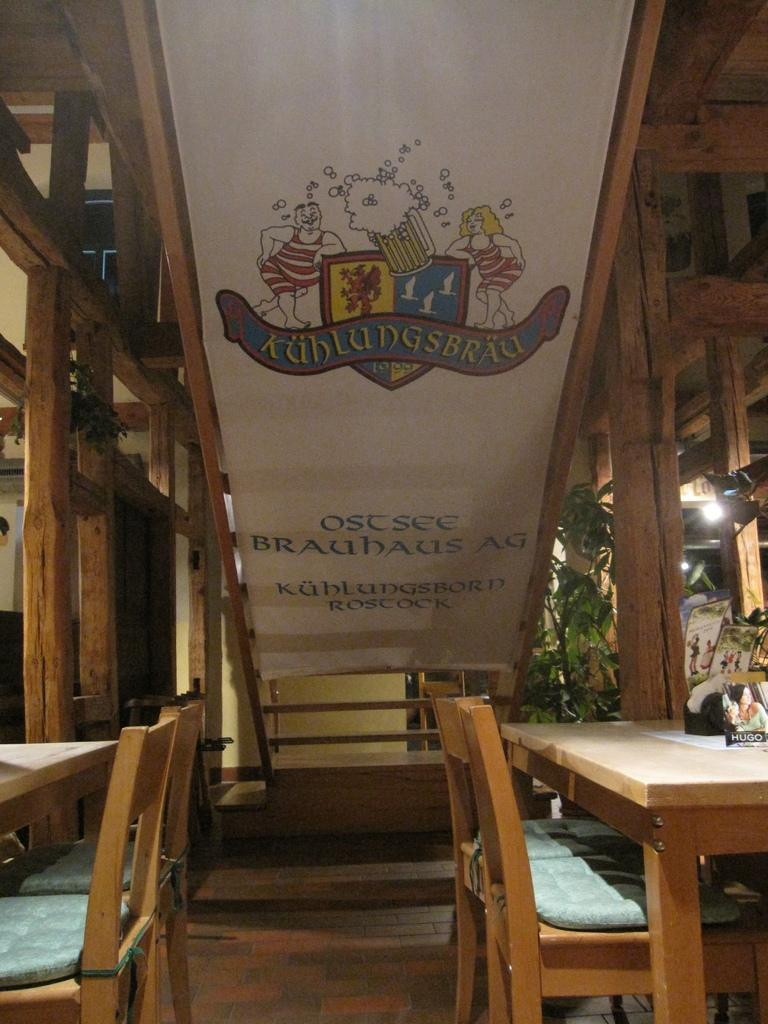What type of furniture is present in the image? There are tables and chairs in the image. What can be seen to the right in the image? There are boards to the right in the image. What is visible in the background of the image? There are boards, plants, light, and wooden poles in the background of the image. Can you tell me how many ears are visible in the image? There are no ears present in the image. What type of downtown area can be seen in the image? There is no downtown area depicted in the image. 